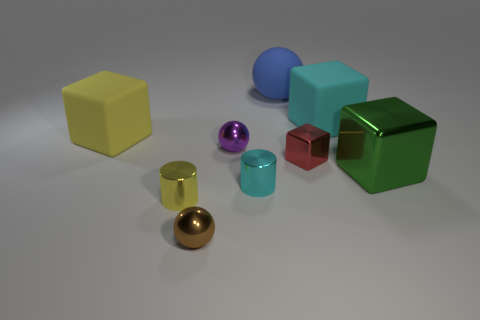What are the different colors of the objects? In this image, there's a spectrum of colors: yellow, blue, red, green, purple, gold, aquamarine, and transparent with a tinge of red. Which object stands out to you the most? The golden sphere catches the eye due to its shiny surface and the way it contrasts with the matte textures of the other objects. 